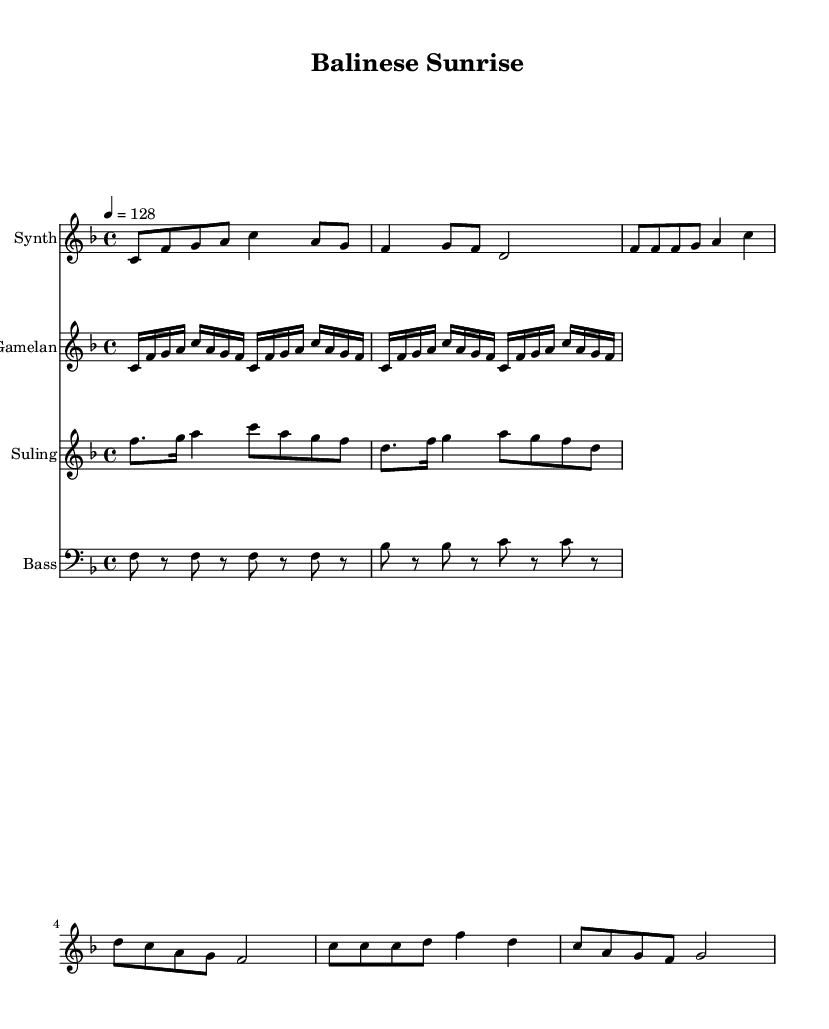What is the key signature of this music? The key signature indicates that the piece is in F major, which has one flat (B flat). This can be identified in the beginning of the score where the B flat is notated.
Answer: F major What is the time signature of the piece? The time signature is represented in the score by the notation shown at the beginning, which is 4/4. This indicates that there are four beats in a measure and the quarter note receives one beat.
Answer: 4/4 What is the tempo marking? The tempo marking in the score indicates a tempo of 128 beats per minute. This is listed above the staff.
Answer: 128 Which instruments are featured in this score? The sheet music specifies four instruments: Synth, Gamelan, Suling, and Bass. Each is indicated at the beginning of its respective staff.
Answer: Synth, Gamelan, Suling, Bass How many times does the Gamelan ostinato repeat in the score? The Gamelan ostinato section explicitly states to repeat two times within the score. This can be noted with the "repeat unfold 2" instruction present above the Gamelan staff.
Answer: 2 What type of rhythm does the suling melody have during the verse? The rhythm of the suling melody is characterized by a mix of eighth notes and dotted notes with a 4/4 time signature. This is observable in the notation where eighth notes and dotted notes are shown.
Answer: Eighth notes and dotted notes What is the main theme of the synth melody in terms of starting note? The main theme of the synth melody starts on the note C. This is the first note played in the melody as indicated in the score.
Answer: C 